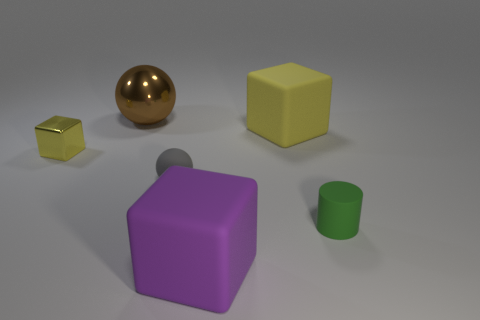What is the color of the other block that is made of the same material as the purple cube?
Make the answer very short. Yellow. What number of other purple things are the same material as the large purple object?
Provide a short and direct response. 0. Are the small green cylinder and the block that is left of the brown metal thing made of the same material?
Offer a terse response. No. What number of objects are metallic things that are on the left side of the tiny green cylinder or big purple rubber objects?
Provide a short and direct response. 3. There is a yellow metal block that is left of the small thing that is to the right of the big thing in front of the small green matte object; how big is it?
Offer a very short reply. Small. There is a large object that is the same color as the tiny shiny thing; what material is it?
Your response must be concise. Rubber. Is there any other thing that is the same shape as the large purple object?
Your answer should be very brief. Yes. How big is the cube that is in front of the ball that is in front of the large yellow rubber block?
Keep it short and to the point. Large. What number of large objects are brown metallic things or purple matte blocks?
Your answer should be very brief. 2. Is the number of big spheres less than the number of big gray shiny cylinders?
Offer a very short reply. No. 